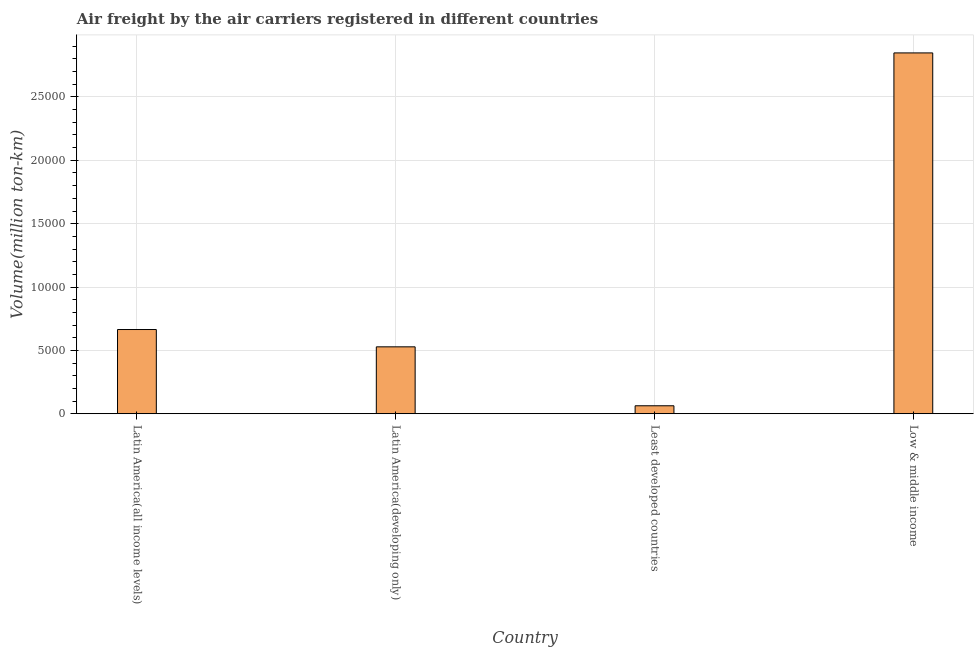Does the graph contain any zero values?
Provide a short and direct response. No. What is the title of the graph?
Offer a terse response. Air freight by the air carriers registered in different countries. What is the label or title of the X-axis?
Provide a short and direct response. Country. What is the label or title of the Y-axis?
Provide a succinct answer. Volume(million ton-km). What is the air freight in Latin America(all income levels)?
Provide a succinct answer. 6647.06. Across all countries, what is the maximum air freight?
Your answer should be very brief. 2.85e+04. Across all countries, what is the minimum air freight?
Keep it short and to the point. 628.93. In which country was the air freight minimum?
Offer a terse response. Least developed countries. What is the sum of the air freight?
Provide a succinct answer. 4.10e+04. What is the difference between the air freight in Latin America(all income levels) and Least developed countries?
Give a very brief answer. 6018.13. What is the average air freight per country?
Give a very brief answer. 1.03e+04. What is the median air freight?
Make the answer very short. 5963.52. In how many countries, is the air freight greater than 1000 million ton-km?
Ensure brevity in your answer.  3. What is the ratio of the air freight in Latin America(all income levels) to that in Latin America(developing only)?
Make the answer very short. 1.26. Is the air freight in Latin America(all income levels) less than that in Least developed countries?
Provide a short and direct response. No. Is the difference between the air freight in Latin America(developing only) and Low & middle income greater than the difference between any two countries?
Your answer should be very brief. No. What is the difference between the highest and the second highest air freight?
Your response must be concise. 2.18e+04. Is the sum of the air freight in Latin America(all income levels) and Least developed countries greater than the maximum air freight across all countries?
Your answer should be very brief. No. What is the difference between the highest and the lowest air freight?
Your answer should be very brief. 2.78e+04. How many countries are there in the graph?
Keep it short and to the point. 4. What is the Volume(million ton-km) in Latin America(all income levels)?
Your answer should be very brief. 6647.06. What is the Volume(million ton-km) of Latin America(developing only)?
Your answer should be compact. 5279.97. What is the Volume(million ton-km) in Least developed countries?
Provide a succinct answer. 628.93. What is the Volume(million ton-km) of Low & middle income?
Offer a terse response. 2.85e+04. What is the difference between the Volume(million ton-km) in Latin America(all income levels) and Latin America(developing only)?
Give a very brief answer. 1367.09. What is the difference between the Volume(million ton-km) in Latin America(all income levels) and Least developed countries?
Your answer should be very brief. 6018.13. What is the difference between the Volume(million ton-km) in Latin America(all income levels) and Low & middle income?
Offer a very short reply. -2.18e+04. What is the difference between the Volume(million ton-km) in Latin America(developing only) and Least developed countries?
Offer a very short reply. 4651.04. What is the difference between the Volume(million ton-km) in Latin America(developing only) and Low & middle income?
Your response must be concise. -2.32e+04. What is the difference between the Volume(million ton-km) in Least developed countries and Low & middle income?
Ensure brevity in your answer.  -2.78e+04. What is the ratio of the Volume(million ton-km) in Latin America(all income levels) to that in Latin America(developing only)?
Provide a succinct answer. 1.26. What is the ratio of the Volume(million ton-km) in Latin America(all income levels) to that in Least developed countries?
Your answer should be compact. 10.57. What is the ratio of the Volume(million ton-km) in Latin America(all income levels) to that in Low & middle income?
Make the answer very short. 0.23. What is the ratio of the Volume(million ton-km) in Latin America(developing only) to that in Least developed countries?
Give a very brief answer. 8.39. What is the ratio of the Volume(million ton-km) in Latin America(developing only) to that in Low & middle income?
Offer a very short reply. 0.18. What is the ratio of the Volume(million ton-km) in Least developed countries to that in Low & middle income?
Your answer should be compact. 0.02. 